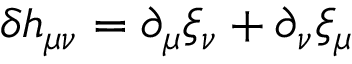Convert formula to latex. <formula><loc_0><loc_0><loc_500><loc_500>\delta h _ { \mu \nu } = \partial _ { \mu } \xi _ { \nu } + \partial _ { \nu } \xi _ { \mu }</formula> 